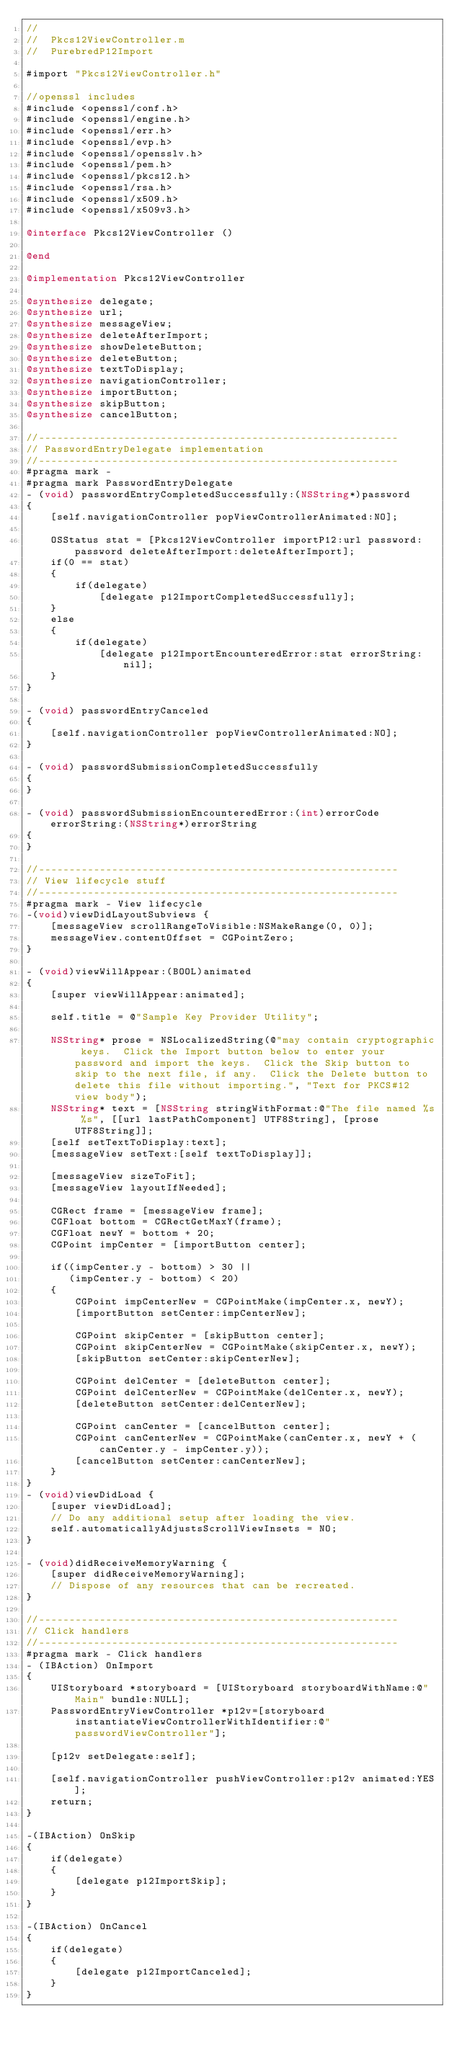Convert code to text. <code><loc_0><loc_0><loc_500><loc_500><_ObjectiveC_>//
//  Pkcs12ViewController.m
//  PurebredP12Import

#import "Pkcs12ViewController.h"

//openssl includes
#include <openssl/conf.h>
#include <openssl/engine.h>
#include <openssl/err.h>
#include <openssl/evp.h>
#include <openssl/opensslv.h>
#include <openssl/pem.h>
#include <openssl/pkcs12.h>
#include <openssl/rsa.h>
#include <openssl/x509.h>
#include <openssl/x509v3.h>

@interface Pkcs12ViewController ()

@end

@implementation Pkcs12ViewController

@synthesize delegate;
@synthesize url;
@synthesize messageView;
@synthesize deleteAfterImport;
@synthesize showDeleteButton;
@synthesize deleteButton;
@synthesize textToDisplay;
@synthesize navigationController;
@synthesize importButton;
@synthesize skipButton;
@synthesize cancelButton;

//-----------------------------------------------------------
// PasswordEntryDelegate implementation
//-----------------------------------------------------------
#pragma mark -
#pragma mark PasswordEntryDelegate
- (void) passwordEntryCompletedSuccessfully:(NSString*)password
{
    [self.navigationController popViewControllerAnimated:NO];
    
    OSStatus stat = [Pkcs12ViewController importP12:url password:password deleteAfterImport:deleteAfterImport];
    if(0 == stat)
    {
        if(delegate)
            [delegate p12ImportCompletedSuccessfully];
    }
    else
    {
        if(delegate)
            [delegate p12ImportEncounteredError:stat errorString:nil];
    }
}

- (void) passwordEntryCanceled
{
    [self.navigationController popViewControllerAnimated:NO];
}

- (void) passwordSubmissionCompletedSuccessfully
{
}

- (void) passwordSubmissionEncounteredError:(int)errorCode errorString:(NSString*)errorString
{
}

//-----------------------------------------------------------
// View lifecycle stuff
//-----------------------------------------------------------
#pragma mark - View lifecycle
-(void)viewDidLayoutSubviews {
    [messageView scrollRangeToVisible:NSMakeRange(0, 0)];
    messageView.contentOffset = CGPointZero;
}

- (void)viewWillAppear:(BOOL)animated
{
    [super viewWillAppear:animated];
    
    self.title = @"Sample Key Provider Utility";
    
    NSString* prose = NSLocalizedString(@"may contain cryptographic keys.  Click the Import button below to enter your password and import the keys.  Click the Skip button to skip to the next file, if any.  Click the Delete button to delete this file without importing.", "Text for PKCS#12 view body");
    NSString* text = [NSString stringWithFormat:@"The file named %s %s", [[url lastPathComponent] UTF8String], [prose UTF8String]];
    [self setTextToDisplay:text];
    [messageView setText:[self textToDisplay]];

    [messageView sizeToFit];
    [messageView layoutIfNeeded];
    
    CGRect frame = [messageView frame];
    CGFloat bottom = CGRectGetMaxY(frame);
    CGFloat newY = bottom + 20;
    CGPoint impCenter = [importButton center];
    
    if((impCenter.y - bottom) > 30 ||
       (impCenter.y - bottom) < 20)
    {
        CGPoint impCenterNew = CGPointMake(impCenter.x, newY);
        [importButton setCenter:impCenterNew];
        
        CGPoint skipCenter = [skipButton center];
        CGPoint skipCenterNew = CGPointMake(skipCenter.x, newY);
        [skipButton setCenter:skipCenterNew];
        
        CGPoint delCenter = [deleteButton center];
        CGPoint delCenterNew = CGPointMake(delCenter.x, newY);
        [deleteButton setCenter:delCenterNew];
        
        CGPoint canCenter = [cancelButton center];
        CGPoint canCenterNew = CGPointMake(canCenter.x, newY + (canCenter.y - impCenter.y));
        [cancelButton setCenter:canCenterNew];
    }
}
- (void)viewDidLoad {
    [super viewDidLoad];
    // Do any additional setup after loading the view.
    self.automaticallyAdjustsScrollViewInsets = NO;
}

- (void)didReceiveMemoryWarning {
    [super didReceiveMemoryWarning];
    // Dispose of any resources that can be recreated.
}

//-----------------------------------------------------------
// Click handlers
//-----------------------------------------------------------
#pragma mark - Click handlers
- (IBAction) OnImport
{
    UIStoryboard *storyboard = [UIStoryboard storyboardWithName:@"Main" bundle:NULL];
    PasswordEntryViewController *p12v=[storyboard instantiateViewControllerWithIdentifier:@"passwordViewController"];
    
    [p12v setDelegate:self];
    
    [self.navigationController pushViewController:p12v animated:YES];
    return;
}

-(IBAction) OnSkip
{
    if(delegate)
    {
        [delegate p12ImportSkip];
    }
}

-(IBAction) OnCancel
{
    if(delegate)
    {
        [delegate p12ImportCanceled];
    }
}
</code> 